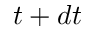Convert formula to latex. <formula><loc_0><loc_0><loc_500><loc_500>t + d t</formula> 